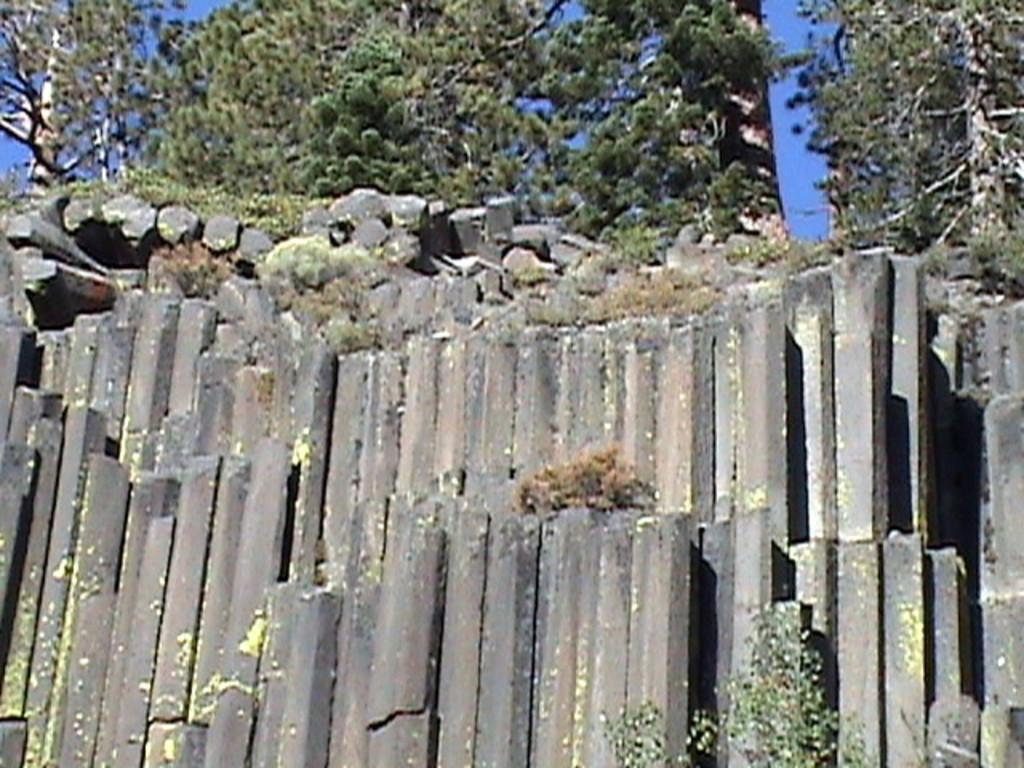What type of natural elements can be seen in the image? There are rocks, plants, and trees in the image. Can you describe the vegetation present in the image? There are plants and trees in the image. How many boys are visible in the image? There are no boys present in the image; it features rocks, plants, and trees. What type of insect can be seen flying around the trees in the image? There is no insect, specifically a fly, present in the image. 